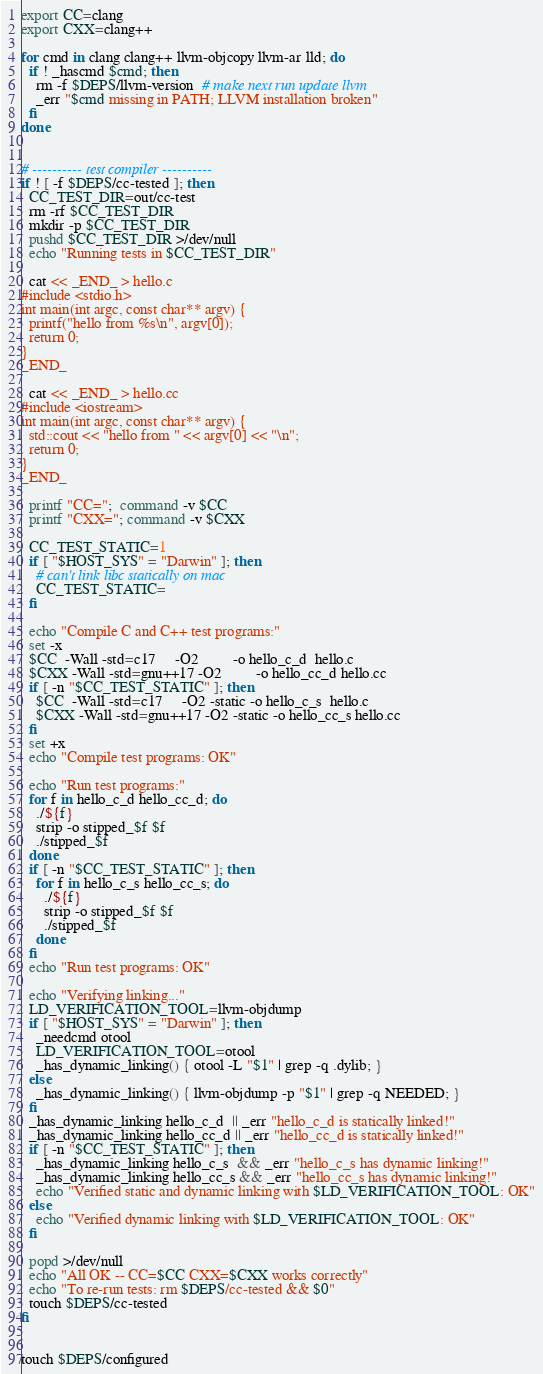<code> <loc_0><loc_0><loc_500><loc_500><_Bash_>export CC=clang
export CXX=clang++

for cmd in clang clang++ llvm-objcopy llvm-ar lld; do
  if ! _hascmd $cmd; then
    rm -f $DEPS/llvm-version  # make next run update llvm
    _err "$cmd missing in PATH; LLVM installation broken"
  fi
done


# ---------- test compiler ----------
if ! [ -f $DEPS/cc-tested ]; then
  CC_TEST_DIR=out/cc-test
  rm -rf $CC_TEST_DIR
  mkdir -p $CC_TEST_DIR
  pushd $CC_TEST_DIR >/dev/null
  echo "Running tests in $CC_TEST_DIR"

  cat << _END_ > hello.c
#include <stdio.h>
int main(int argc, const char** argv) {
  printf("hello from %s\n", argv[0]);
  return 0;
}
_END_

  cat << _END_ > hello.cc
#include <iostream>
int main(int argc, const char** argv) {
  std::cout << "hello from " << argv[0] << "\n";
  return 0;
}
_END_

  printf "CC=";  command -v $CC
  printf "CXX="; command -v $CXX

  CC_TEST_STATIC=1
  if [ "$HOST_SYS" = "Darwin" ]; then
    # can't link libc statically on mac
    CC_TEST_STATIC=
  fi

  echo "Compile C and C++ test programs:"
  set -x
  $CC  -Wall -std=c17     -O2         -o hello_c_d  hello.c
  $CXX -Wall -std=gnu++17 -O2         -o hello_cc_d hello.cc
  if [ -n "$CC_TEST_STATIC" ]; then
    $CC  -Wall -std=c17     -O2 -static -o hello_c_s  hello.c
    $CXX -Wall -std=gnu++17 -O2 -static -o hello_cc_s hello.cc
  fi
  set +x
  echo "Compile test programs: OK"

  echo "Run test programs:"
  for f in hello_c_d hello_cc_d; do
    ./${f}
    strip -o stipped_$f $f
    ./stipped_$f
  done
  if [ -n "$CC_TEST_STATIC" ]; then
    for f in hello_c_s hello_cc_s; do
      ./${f}
      strip -o stipped_$f $f
      ./stipped_$f
    done
  fi
  echo "Run test programs: OK"

  echo "Verifying linking..."
  LD_VERIFICATION_TOOL=llvm-objdump
  if [ "$HOST_SYS" = "Darwin" ]; then
    _needcmd otool
    LD_VERIFICATION_TOOL=otool
    _has_dynamic_linking() { otool -L "$1" | grep -q .dylib; }
  else
    _has_dynamic_linking() { llvm-objdump -p "$1" | grep -q NEEDED; }
  fi
  _has_dynamic_linking hello_c_d  || _err "hello_c_d is statically linked!"
  _has_dynamic_linking hello_cc_d || _err "hello_cc_d is statically linked!"
  if [ -n "$CC_TEST_STATIC" ]; then
    _has_dynamic_linking hello_c_s  && _err "hello_c_s has dynamic linking!"
    _has_dynamic_linking hello_cc_s && _err "hello_cc_s has dynamic linking!"
    echo "Verified static and dynamic linking with $LD_VERIFICATION_TOOL: OK"
  else
    echo "Verified dynamic linking with $LD_VERIFICATION_TOOL: OK"
  fi

  popd >/dev/null
  echo "All OK -- CC=$CC CXX=$CXX works correctly"
  echo "To re-run tests: rm $DEPS/cc-tested && $0"
  touch $DEPS/cc-tested
fi


touch $DEPS/configured
</code> 